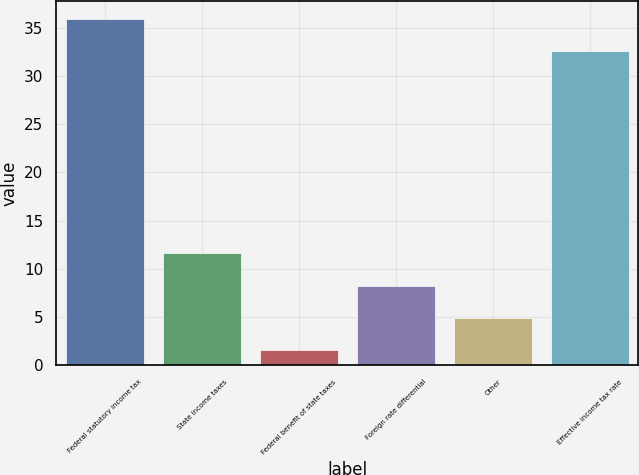Convert chart. <chart><loc_0><loc_0><loc_500><loc_500><bar_chart><fcel>Federal statutory income tax<fcel>State income taxes<fcel>Federal benefit of state taxes<fcel>Foreign rate differential<fcel>Other<fcel>Effective income tax rate<nl><fcel>35.94<fcel>11.62<fcel>1.6<fcel>8.28<fcel>4.94<fcel>32.6<nl></chart> 